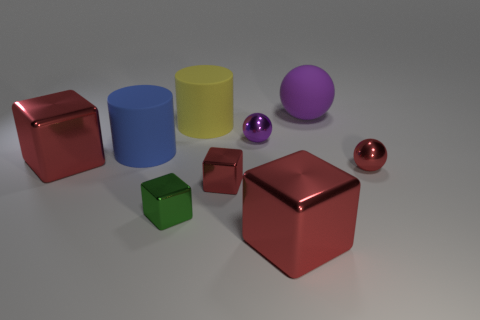Subtract all green metal cubes. How many cubes are left? 3 Subtract all red blocks. How many blocks are left? 1 Subtract all spheres. How many objects are left? 6 Subtract 4 cubes. How many cubes are left? 0 Subtract all brown cubes. How many green spheres are left? 0 Subtract all green objects. Subtract all large balls. How many objects are left? 7 Add 2 rubber balls. How many rubber balls are left? 3 Add 7 purple objects. How many purple objects exist? 9 Subtract 0 gray balls. How many objects are left? 9 Subtract all brown blocks. Subtract all cyan spheres. How many blocks are left? 4 